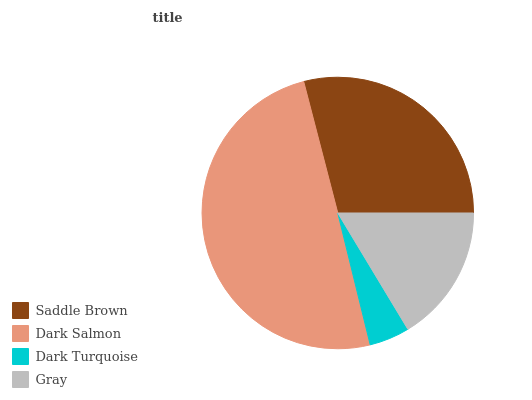Is Dark Turquoise the minimum?
Answer yes or no. Yes. Is Dark Salmon the maximum?
Answer yes or no. Yes. Is Dark Salmon the minimum?
Answer yes or no. No. Is Dark Turquoise the maximum?
Answer yes or no. No. Is Dark Salmon greater than Dark Turquoise?
Answer yes or no. Yes. Is Dark Turquoise less than Dark Salmon?
Answer yes or no. Yes. Is Dark Turquoise greater than Dark Salmon?
Answer yes or no. No. Is Dark Salmon less than Dark Turquoise?
Answer yes or no. No. Is Saddle Brown the high median?
Answer yes or no. Yes. Is Gray the low median?
Answer yes or no. Yes. Is Dark Salmon the high median?
Answer yes or no. No. Is Dark Turquoise the low median?
Answer yes or no. No. 